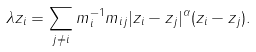Convert formula to latex. <formula><loc_0><loc_0><loc_500><loc_500>\lambda z _ { i } = \sum _ { j \neq i } m _ { i } ^ { - 1 } m _ { i j } | z _ { i } - z _ { j } | ^ { \alpha } ( z _ { i } - z _ { j } ) .</formula> 